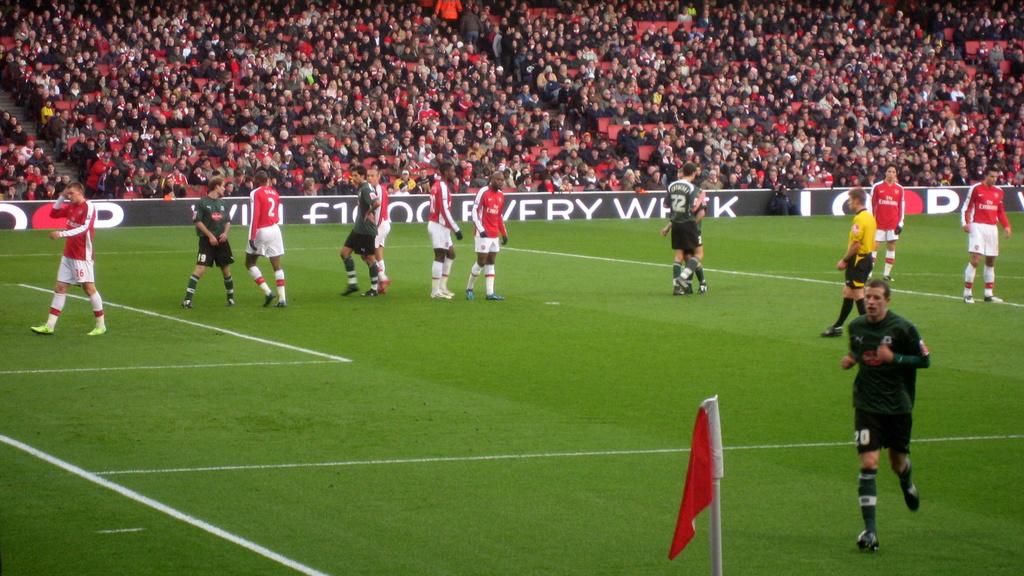What is the player number of the green player running towards the camera?
Provide a succinct answer. 20. What is the number of the red jersey second from left?
Provide a short and direct response. 2. 